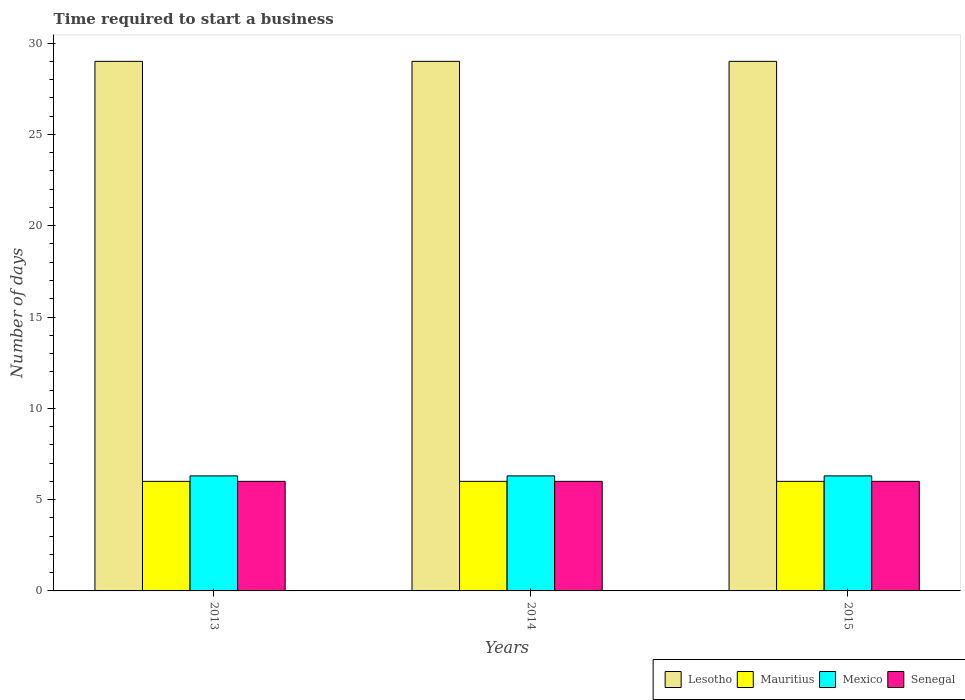How many different coloured bars are there?
Offer a terse response. 4. Are the number of bars on each tick of the X-axis equal?
Provide a short and direct response. Yes. What is the label of the 1st group of bars from the left?
Give a very brief answer. 2013. Across all years, what is the maximum number of days required to start a business in Senegal?
Give a very brief answer. 6. Across all years, what is the minimum number of days required to start a business in Mexico?
Your answer should be very brief. 6.3. What is the total number of days required to start a business in Senegal in the graph?
Your response must be concise. 18. What is the difference between the number of days required to start a business in Lesotho in 2015 and the number of days required to start a business in Mexico in 2014?
Give a very brief answer. 22.7. In the year 2015, what is the difference between the number of days required to start a business in Mexico and number of days required to start a business in Senegal?
Give a very brief answer. 0.3. What is the ratio of the number of days required to start a business in Mexico in 2014 to that in 2015?
Your answer should be very brief. 1. Is the difference between the number of days required to start a business in Mexico in 2013 and 2015 greater than the difference between the number of days required to start a business in Senegal in 2013 and 2015?
Your answer should be very brief. No. What is the difference between the highest and the second highest number of days required to start a business in Lesotho?
Provide a short and direct response. 0. In how many years, is the number of days required to start a business in Mauritius greater than the average number of days required to start a business in Mauritius taken over all years?
Keep it short and to the point. 0. Is it the case that in every year, the sum of the number of days required to start a business in Senegal and number of days required to start a business in Mexico is greater than the sum of number of days required to start a business in Lesotho and number of days required to start a business in Mauritius?
Give a very brief answer. Yes. What does the 1st bar from the left in 2013 represents?
Your response must be concise. Lesotho. What does the 3rd bar from the right in 2013 represents?
Provide a short and direct response. Mauritius. Is it the case that in every year, the sum of the number of days required to start a business in Senegal and number of days required to start a business in Mexico is greater than the number of days required to start a business in Mauritius?
Offer a terse response. Yes. How many bars are there?
Provide a succinct answer. 12. How many years are there in the graph?
Your response must be concise. 3. What is the difference between two consecutive major ticks on the Y-axis?
Give a very brief answer. 5. How many legend labels are there?
Make the answer very short. 4. How are the legend labels stacked?
Offer a very short reply. Horizontal. What is the title of the graph?
Offer a terse response. Time required to start a business. What is the label or title of the Y-axis?
Give a very brief answer. Number of days. What is the Number of days of Lesotho in 2013?
Ensure brevity in your answer.  29. What is the Number of days in Mauritius in 2013?
Give a very brief answer. 6. What is the Number of days in Mexico in 2013?
Offer a very short reply. 6.3. What is the Number of days of Senegal in 2013?
Offer a very short reply. 6. What is the Number of days in Mexico in 2014?
Ensure brevity in your answer.  6.3. What is the Number of days of Mauritius in 2015?
Provide a succinct answer. 6. What is the Number of days of Senegal in 2015?
Ensure brevity in your answer.  6. Across all years, what is the maximum Number of days in Mauritius?
Provide a short and direct response. 6. Across all years, what is the minimum Number of days of Lesotho?
Provide a short and direct response. 29. Across all years, what is the minimum Number of days in Mexico?
Ensure brevity in your answer.  6.3. Across all years, what is the minimum Number of days of Senegal?
Offer a very short reply. 6. What is the total Number of days in Mauritius in the graph?
Provide a short and direct response. 18. What is the total Number of days of Mexico in the graph?
Provide a short and direct response. 18.9. What is the total Number of days of Senegal in the graph?
Your response must be concise. 18. What is the difference between the Number of days of Lesotho in 2013 and that in 2014?
Offer a very short reply. 0. What is the difference between the Number of days in Lesotho in 2013 and that in 2015?
Make the answer very short. 0. What is the difference between the Number of days of Mauritius in 2013 and that in 2015?
Make the answer very short. 0. What is the difference between the Number of days of Senegal in 2013 and that in 2015?
Offer a terse response. 0. What is the difference between the Number of days in Lesotho in 2014 and that in 2015?
Your response must be concise. 0. What is the difference between the Number of days in Senegal in 2014 and that in 2015?
Make the answer very short. 0. What is the difference between the Number of days of Lesotho in 2013 and the Number of days of Mauritius in 2014?
Give a very brief answer. 23. What is the difference between the Number of days in Lesotho in 2013 and the Number of days in Mexico in 2014?
Provide a short and direct response. 22.7. What is the difference between the Number of days in Mauritius in 2013 and the Number of days in Mexico in 2014?
Your answer should be compact. -0.3. What is the difference between the Number of days in Lesotho in 2013 and the Number of days in Mexico in 2015?
Your answer should be compact. 22.7. What is the difference between the Number of days of Lesotho in 2013 and the Number of days of Senegal in 2015?
Make the answer very short. 23. What is the difference between the Number of days of Mauritius in 2013 and the Number of days of Mexico in 2015?
Ensure brevity in your answer.  -0.3. What is the difference between the Number of days in Lesotho in 2014 and the Number of days in Mexico in 2015?
Offer a terse response. 22.7. What is the difference between the Number of days in Mexico in 2014 and the Number of days in Senegal in 2015?
Your answer should be very brief. 0.3. In the year 2013, what is the difference between the Number of days in Lesotho and Number of days in Mexico?
Offer a very short reply. 22.7. In the year 2013, what is the difference between the Number of days in Mexico and Number of days in Senegal?
Ensure brevity in your answer.  0.3. In the year 2014, what is the difference between the Number of days of Lesotho and Number of days of Mauritius?
Provide a succinct answer. 23. In the year 2014, what is the difference between the Number of days of Lesotho and Number of days of Mexico?
Offer a very short reply. 22.7. In the year 2014, what is the difference between the Number of days of Mauritius and Number of days of Senegal?
Ensure brevity in your answer.  0. In the year 2014, what is the difference between the Number of days in Mexico and Number of days in Senegal?
Give a very brief answer. 0.3. In the year 2015, what is the difference between the Number of days of Lesotho and Number of days of Mauritius?
Your answer should be compact. 23. In the year 2015, what is the difference between the Number of days in Lesotho and Number of days in Mexico?
Your answer should be compact. 22.7. In the year 2015, what is the difference between the Number of days in Mauritius and Number of days in Mexico?
Ensure brevity in your answer.  -0.3. What is the ratio of the Number of days of Mexico in 2013 to that in 2014?
Provide a short and direct response. 1. What is the ratio of the Number of days in Lesotho in 2013 to that in 2015?
Your answer should be very brief. 1. What is the ratio of the Number of days of Mauritius in 2013 to that in 2015?
Your answer should be compact. 1. What is the ratio of the Number of days of Senegal in 2013 to that in 2015?
Make the answer very short. 1. What is the difference between the highest and the second highest Number of days in Lesotho?
Ensure brevity in your answer.  0. What is the difference between the highest and the lowest Number of days of Lesotho?
Keep it short and to the point. 0. What is the difference between the highest and the lowest Number of days in Mauritius?
Provide a succinct answer. 0. 